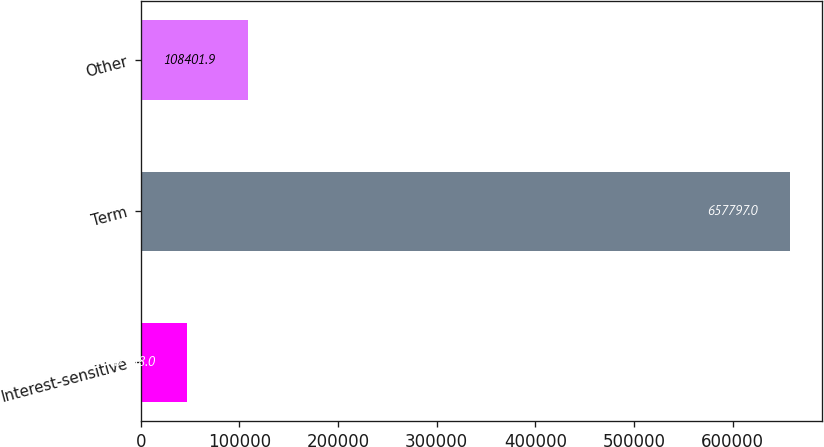Convert chart. <chart><loc_0><loc_0><loc_500><loc_500><bar_chart><fcel>Interest-sensitive<fcel>Term<fcel>Other<nl><fcel>47358<fcel>657797<fcel>108402<nl></chart> 